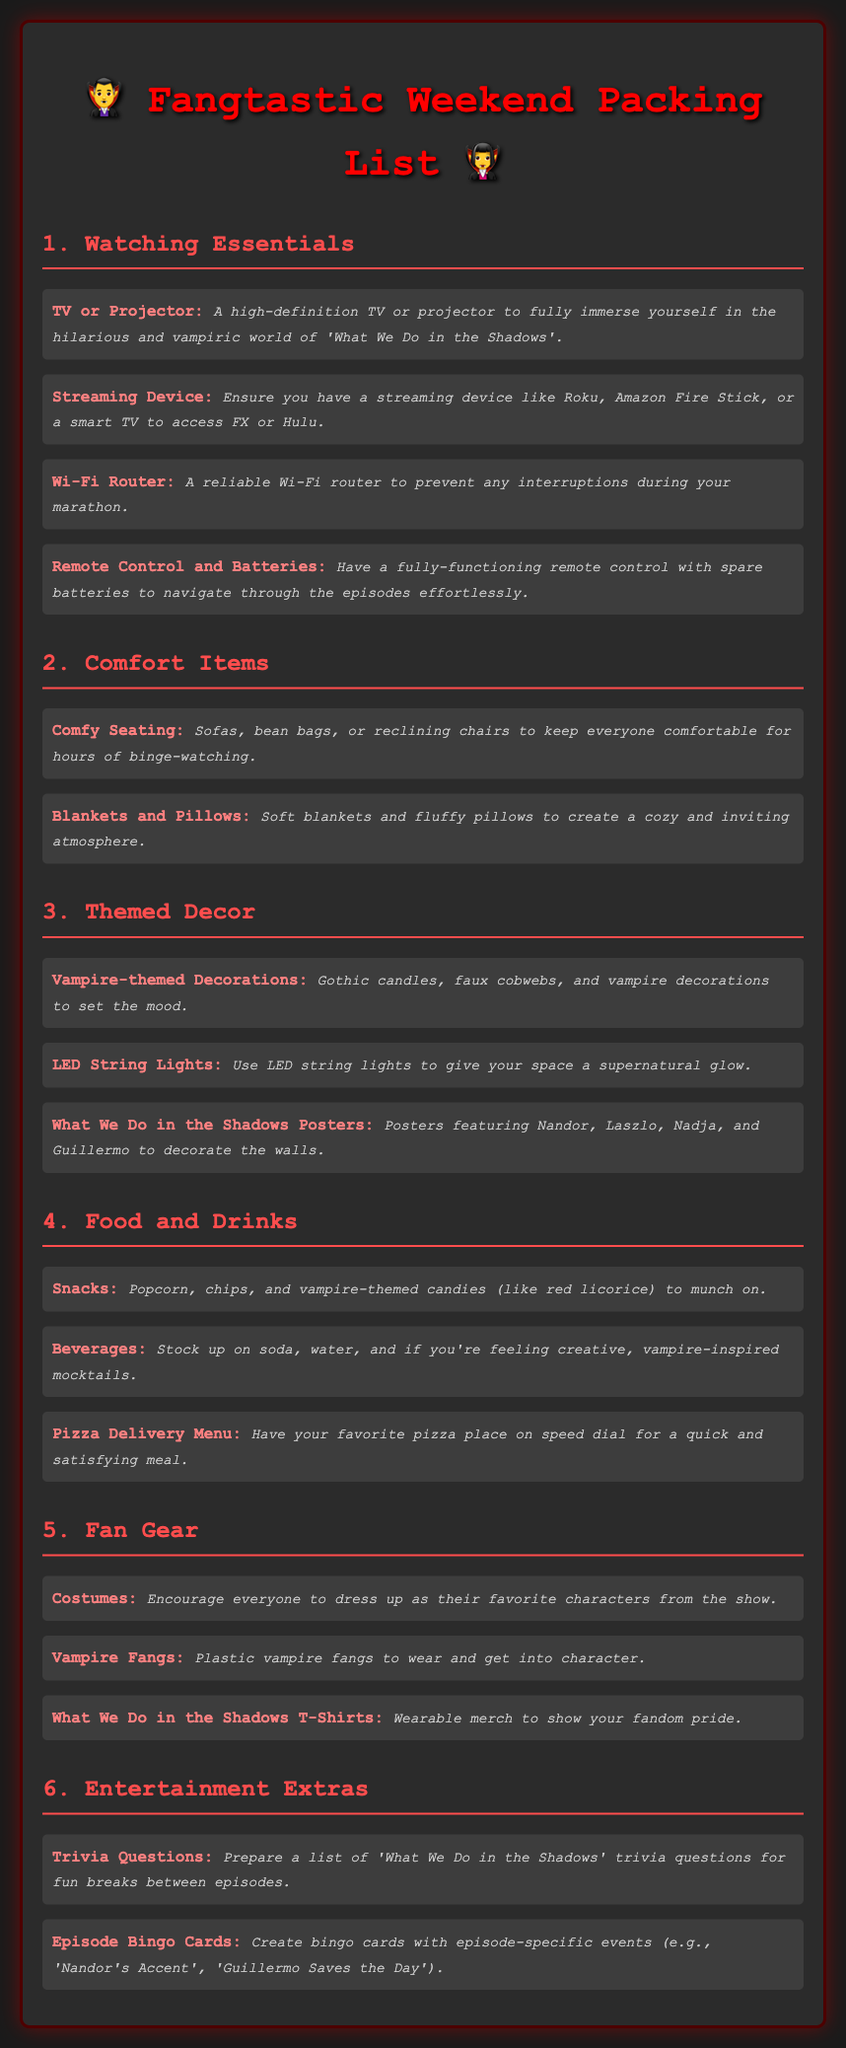what is the title of the packing list? The title of the packing list is prominently displayed at the top of the document.
Answer: Fangtastic Weekend Packing List how many sections are in the list? The packing list is divided into several sections detailing different aspects of the binge-watch marathon.
Answer: 6 what is one item listed under Watching Essentials? Each section contains several items; one of them is highlighted under Watching Essentials.
Answer: TV or Projector which item provides a cozy atmosphere? A specific item in the Comfort Items section is mentioned as creating a cozy environment for the marathon.
Answer: Blankets and Pillows what kind of decorations are suggested in the Themed Decor section? The document provides ideas for decorations that align with the theme of the show.
Answer: Vampire-themed Decorations what does the section on Food and Drinks include? This section contains suggestions related to snacks and beverages for the marathon.
Answer: Snacks how can fans engage during the marathon according to the document? The document outlines a way for fans to interact and have fun during the viewing.
Answer: Trivia Questions what type of clothing is recommended for fan gear? There is a specific article of clothing mentioned for fans to express their fandom.
Answer: What We Do in the Shadows T-Shirts how can observers spice up their marathon experience? The document suggests adding a game element to the viewing party through specific items.
Answer: Episode Bingo Cards 